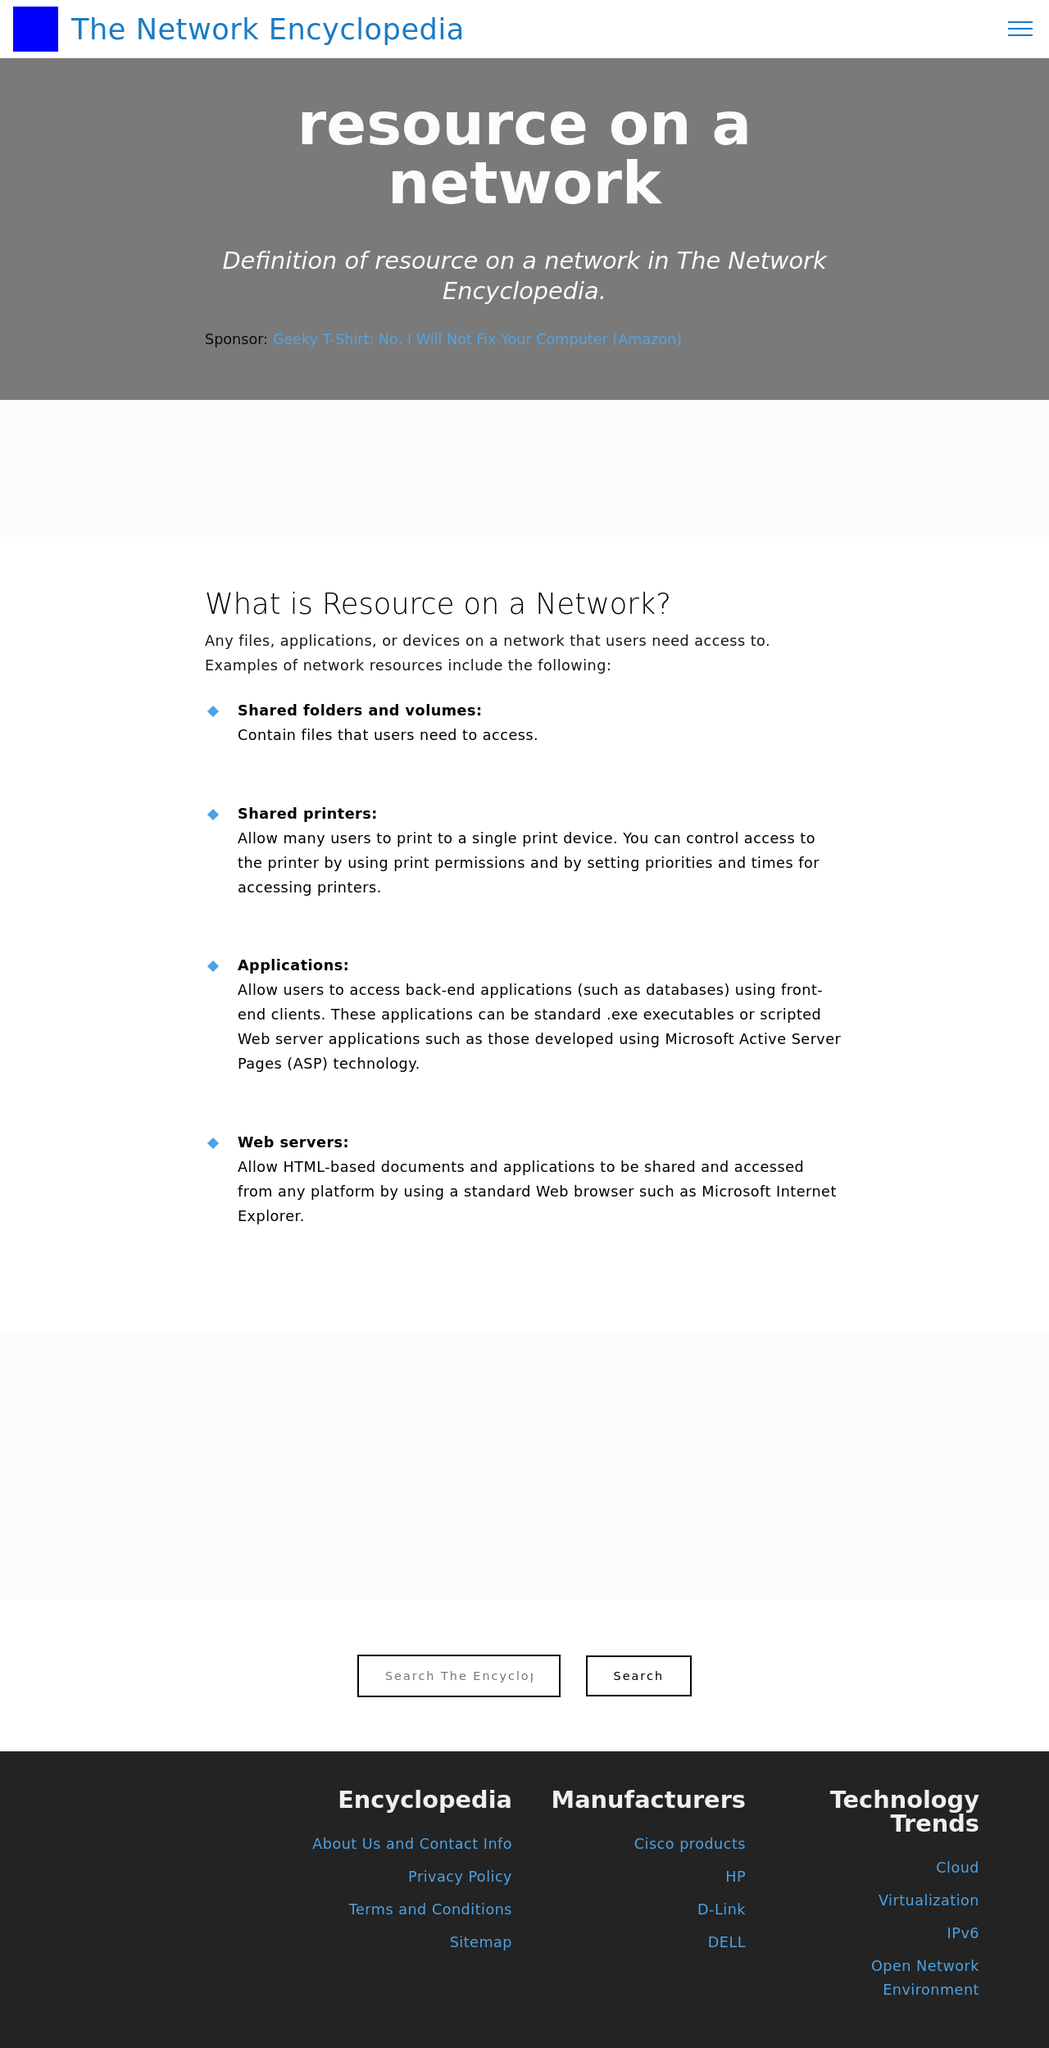Could you detail the process for assembling this website using HTML? To assemble a website similar to the one in the image using HTML, you would typically follow these steps:
1. **Structure**: Create the basic HTML structure using tags like <html>, <head>, and <body>.
2. **Navigation**: Design your navbar using <nav> or <header> tags for easy navigation.
3. **Content**: Use <div>, <section>, and <article> tags to structure different content areas as seen in the image, like sections for 'Resource on a Network', 'Manufacturers', and 'Technology Trends'.
4. **Styling**: Apply CSS to enhance the appearance of your website to match the thematic elements pictured, such as typography, colors, and layout.
5. **Interactive Elements**: Add buttons, forms, or modals using <button>, <form>, or JavaScript to handle user interactions similar to the search field displayed.
6. **Responsiveness**: Make your website adaptable to various devices with responsive design practices, perhaps using a framework like Bootstrap or by applying media queries in your CSS. 